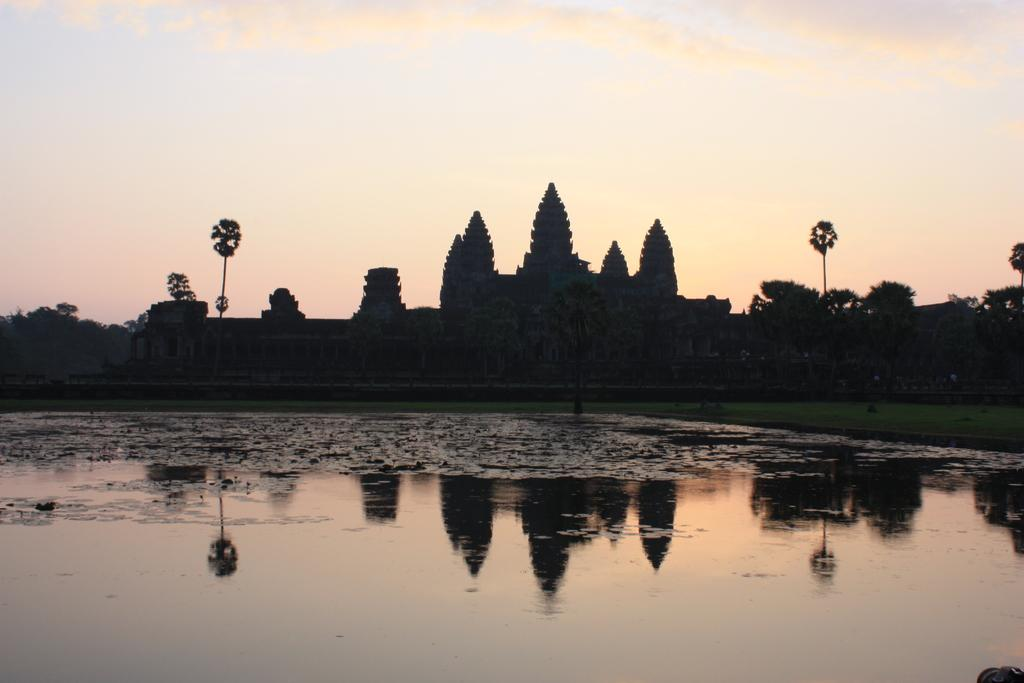What is the primary element visible in the image? There is water in the image. What is located near the water in the image? There is a shoreline in the image. What type of vegetation can be seen in the image? There are trees in the image. What is visible above the water and trees in the image? The sky is visible in the image. What type of sheet is being used to cover the yam in the image? There is no sheet or yam present in the image. 